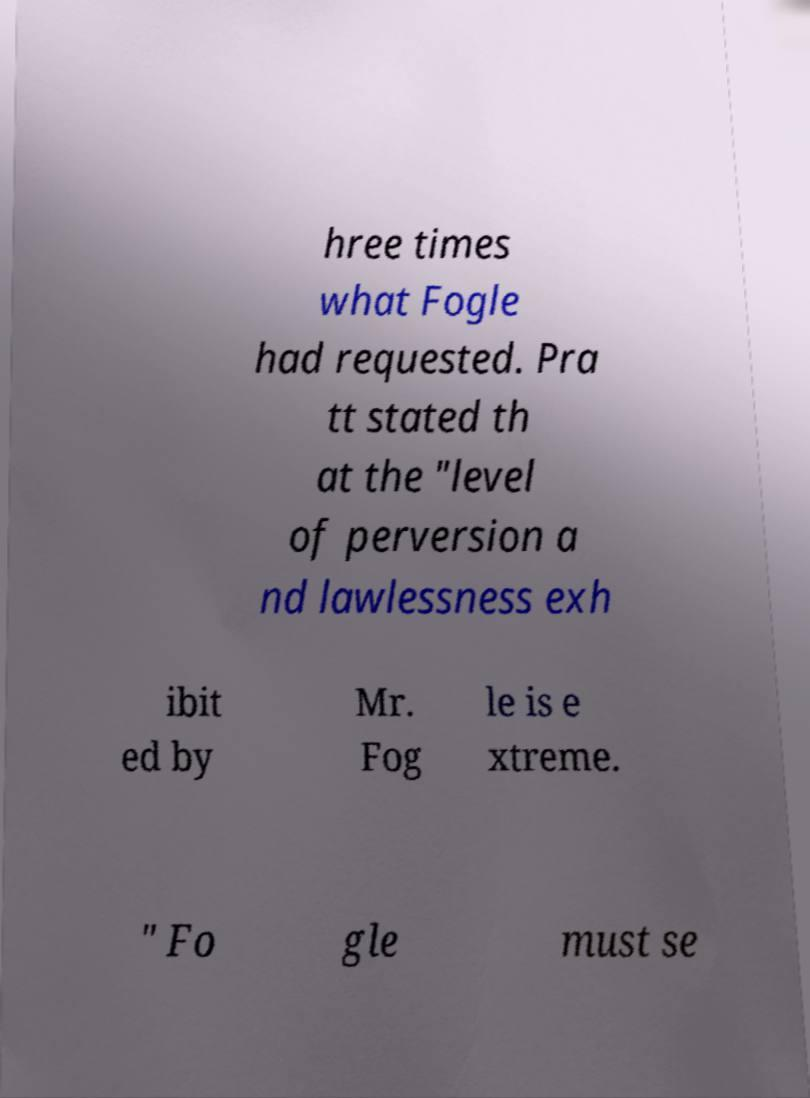Can you read and provide the text displayed in the image?This photo seems to have some interesting text. Can you extract and type it out for me? hree times what Fogle had requested. Pra tt stated th at the "level of perversion a nd lawlessness exh ibit ed by Mr. Fog le is e xtreme. " Fo gle must se 